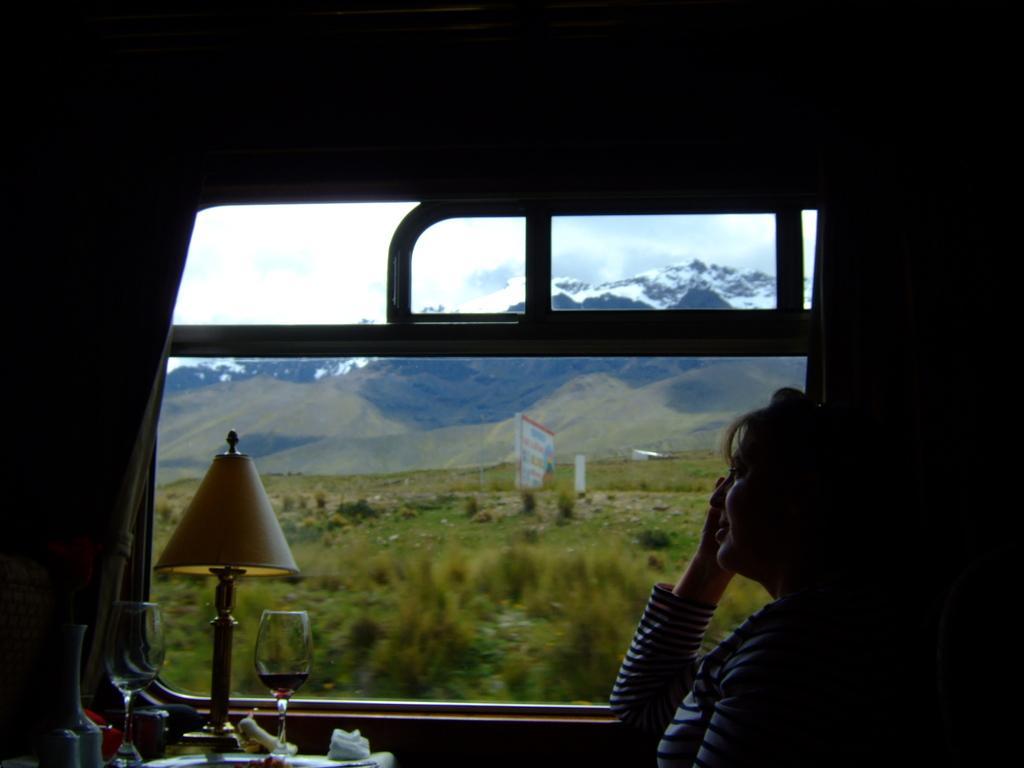How would you summarize this image in a sentence or two? In this image I can see a person, I can also see few glasses, a lamp, few papers on the table. Background I can see plants in green color, a white color board, mountains and the sky is in white color. 